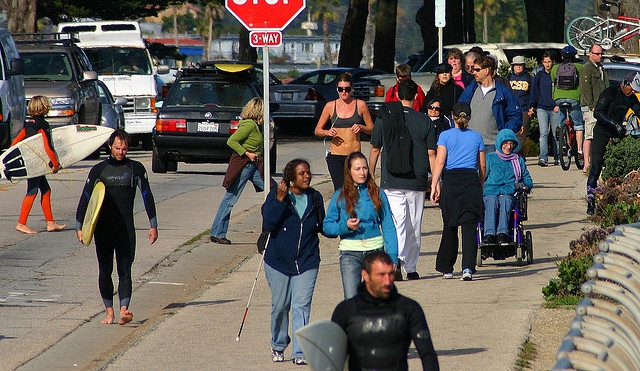Describe the objects in this image and their specific colors. I can see people in black, gray, darkgray, and navy tones, car in black, gray, navy, and lightgray tones, people in black, gray, darkgray, and brown tones, people in black, lightgray, darkgray, and gray tones, and people in black, gray, maroon, and brown tones in this image. 